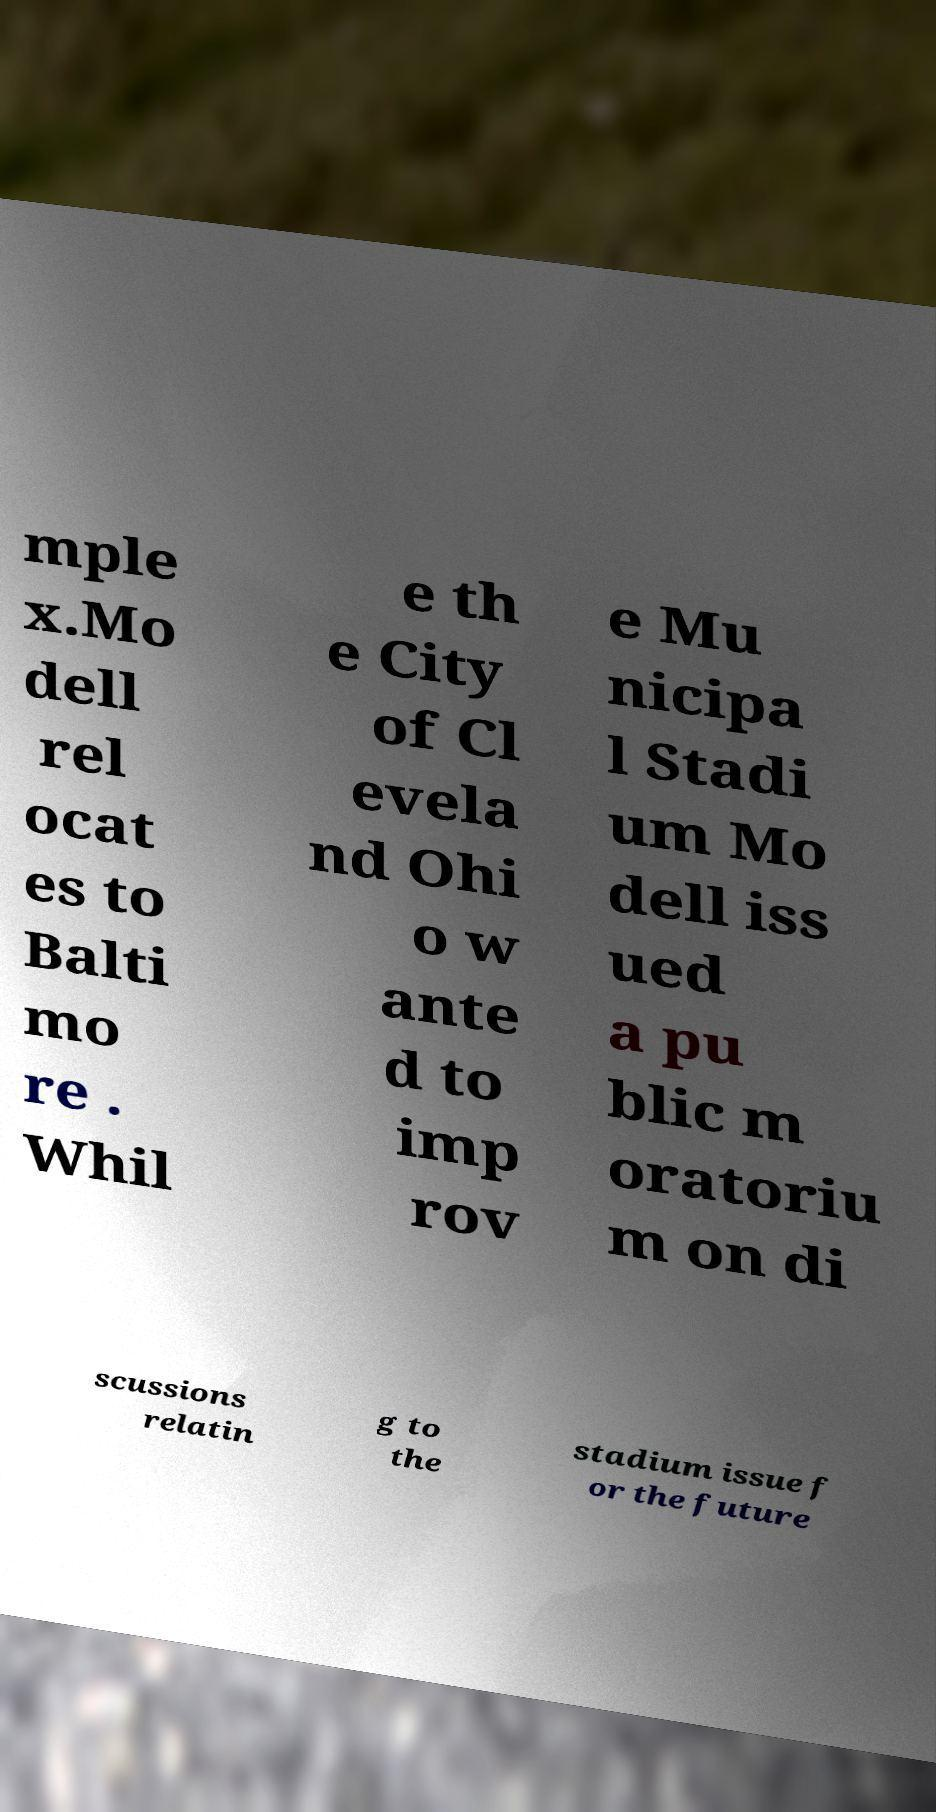Please identify and transcribe the text found in this image. mple x.Mo dell rel ocat es to Balti mo re . Whil e th e City of Cl evela nd Ohi o w ante d to imp rov e Mu nicipa l Stadi um Mo dell iss ued a pu blic m oratoriu m on di scussions relatin g to the stadium issue f or the future 